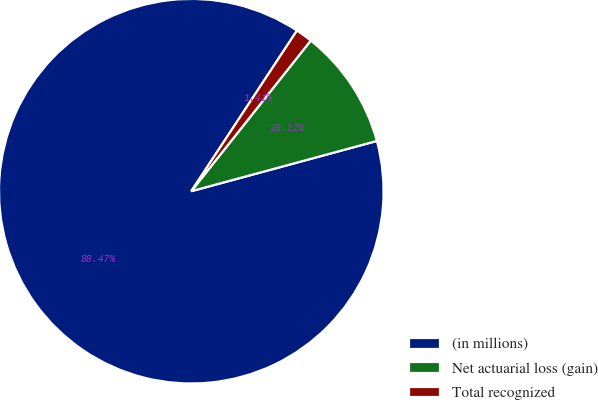<chart> <loc_0><loc_0><loc_500><loc_500><pie_chart><fcel>(in millions)<fcel>Net actuarial loss (gain)<fcel>Total recognized<nl><fcel>88.48%<fcel>10.12%<fcel>1.41%<nl></chart> 